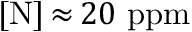<formula> <loc_0><loc_0><loc_500><loc_500>[ N ] \, { \approx } \, 2 0 p p m</formula> 